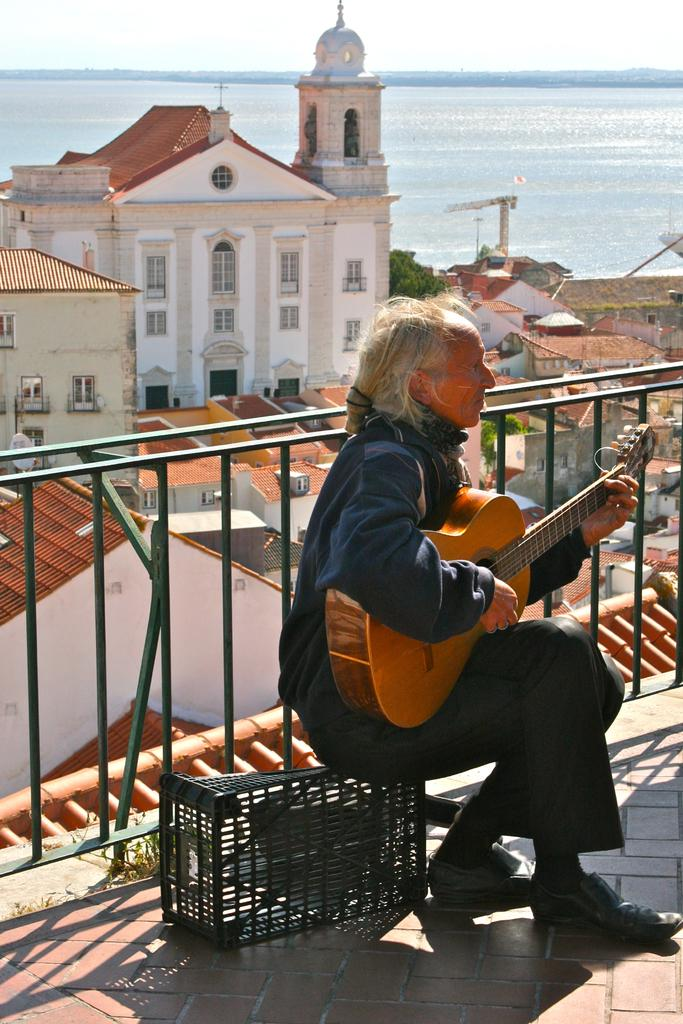What is the man in the image doing? The man is seated and playing a guitar in the image. What can be seen in the background of the image? There are houses and an ocean visible in the image. What type of guide does the man need to play the guitar in the image? There is no indication in the image that the man needs a guide to play the guitar. 